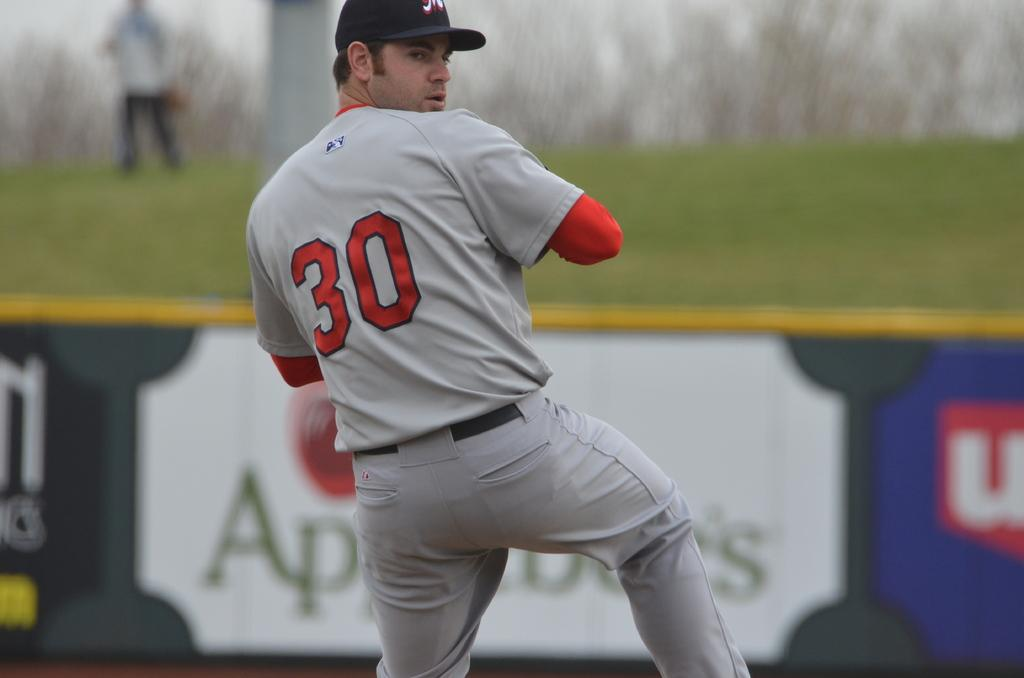Provide a one-sentence caption for the provided image. the number 30 baseball pitcher standing on the mound ready to throw the ball. 